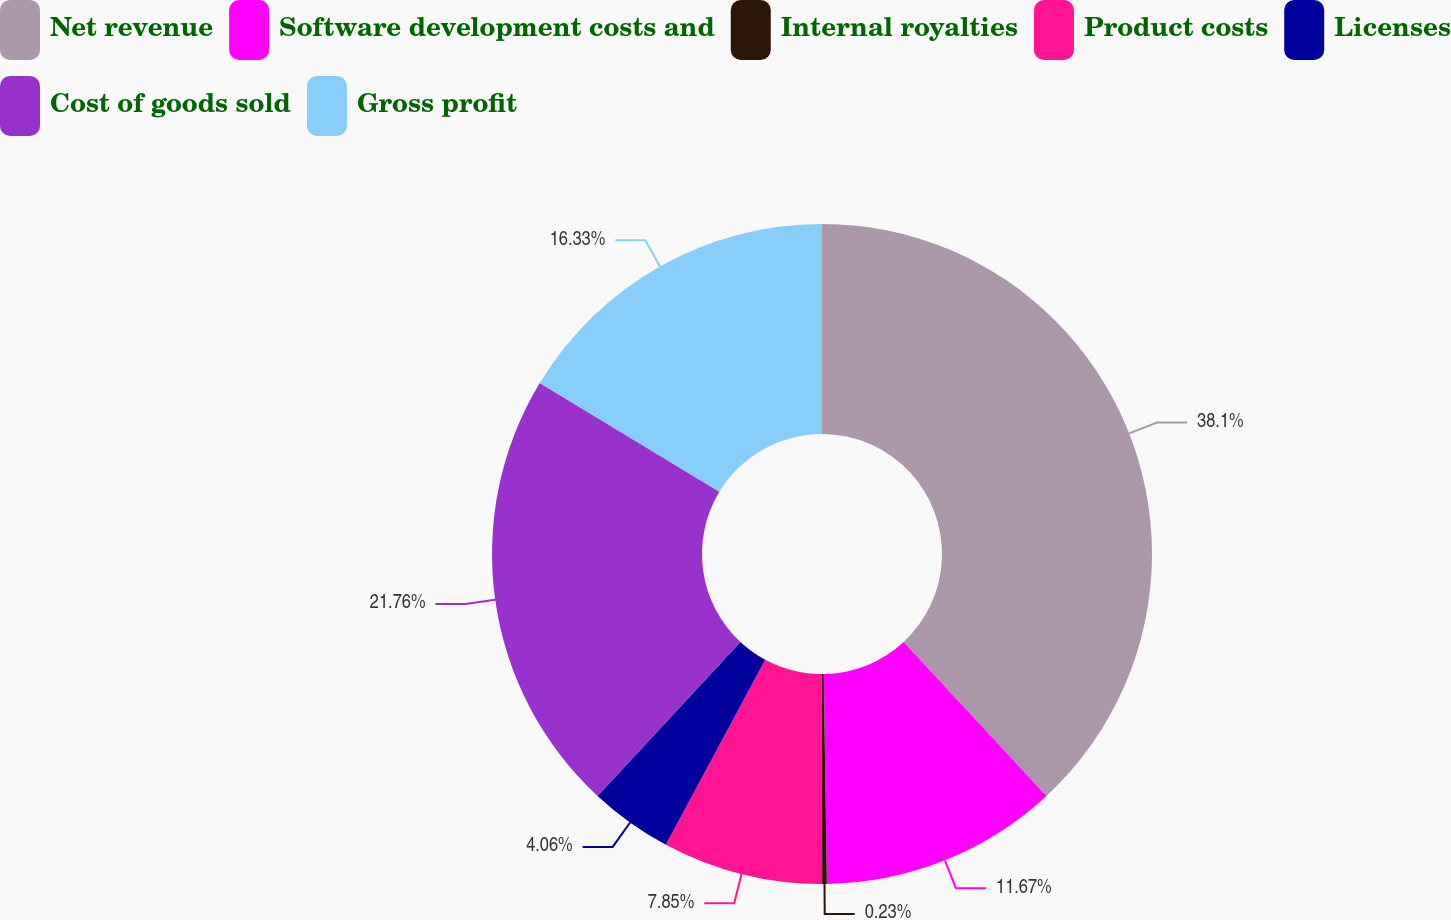Convert chart to OTSL. <chart><loc_0><loc_0><loc_500><loc_500><pie_chart><fcel>Net revenue<fcel>Software development costs and<fcel>Internal royalties<fcel>Product costs<fcel>Licenses<fcel>Cost of goods sold<fcel>Gross profit<nl><fcel>38.09%<fcel>11.67%<fcel>0.23%<fcel>7.85%<fcel>4.06%<fcel>21.76%<fcel>16.33%<nl></chart> 